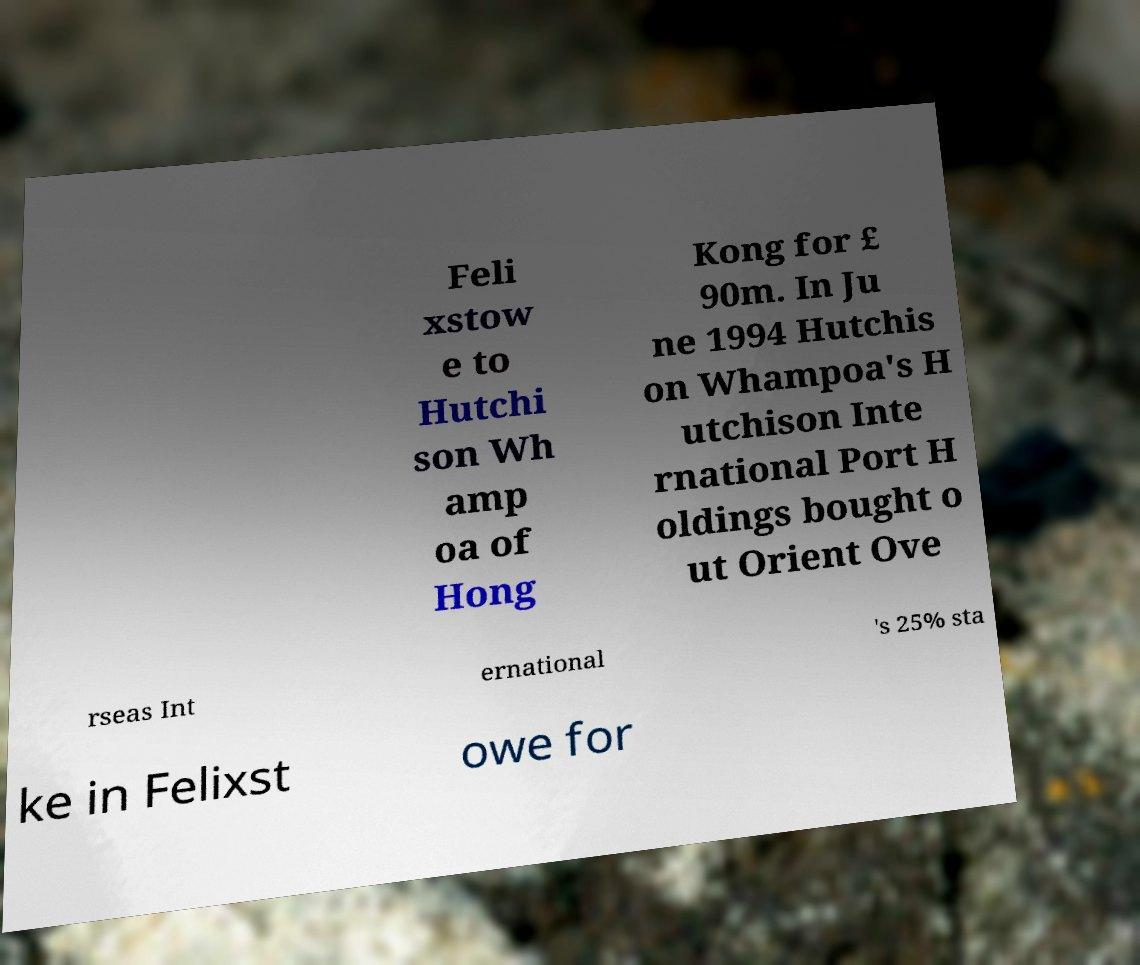I need the written content from this picture converted into text. Can you do that? Feli xstow e to Hutchi son Wh amp oa of Hong Kong for £ 90m. In Ju ne 1994 Hutchis on Whampoa's H utchison Inte rnational Port H oldings bought o ut Orient Ove rseas Int ernational 's 25% sta ke in Felixst owe for 